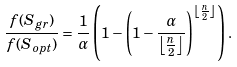<formula> <loc_0><loc_0><loc_500><loc_500>\frac { f ( S _ { g r } ) } { f ( S _ { o p t } ) } = \frac { 1 } { \alpha } \left ( 1 - \left ( 1 - \frac { \alpha } { \left \lfloor \frac { n } { 2 } \right \rfloor } \right ) ^ { \left \lfloor \frac { n } { 2 } \right \rfloor } \right ) .</formula> 